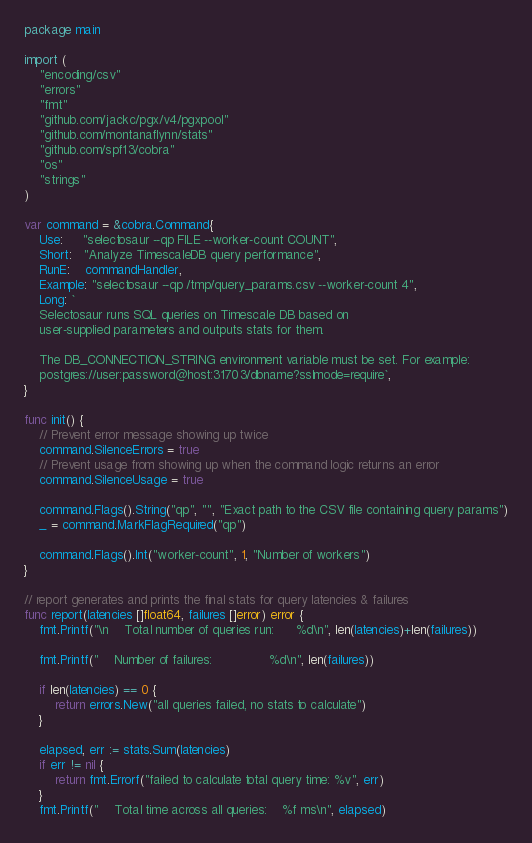<code> <loc_0><loc_0><loc_500><loc_500><_Go_>package main

import (
	"encoding/csv"
	"errors"
	"fmt"
	"github.com/jackc/pgx/v4/pgxpool"
	"github.com/montanaflynn/stats"
	"github.com/spf13/cobra"
	"os"
	"strings"
)

var command = &cobra.Command{
	Use:     "selectosaur --qp FILE --worker-count COUNT",
	Short:   "Analyze TimescaleDB query performance",
	RunE:    commandHandler,
	Example: "selectosaur --qp /tmp/query_params.csv --worker-count 4",
	Long: `
    Selectosaur runs SQL queries on Timescale DB based on
    user-supplied parameters and outputs stats for them.

    The DB_CONNECTION_STRING environment variable must be set. For example:
    postgres://user:password@host:31703/dbname?sslmode=require`,
}

func init() {
	// Prevent error message showing up twice
	command.SilenceErrors = true
	// Prevent usage from showing up when the command logic returns an error
	command.SilenceUsage = true

	command.Flags().String("qp", "", "Exact path to the CSV file containing query params")
	_ = command.MarkFlagRequired("qp")

	command.Flags().Int("worker-count", 1, "Number of workers")
}

// report generates and prints the final stats for query latencies & failures
func report(latencies []float64, failures []error) error {
	fmt.Printf("\n    Total number of queries run:      %d\n", len(latencies)+len(failures))

	fmt.Printf("    Number of failures:               %d\n", len(failures))

	if len(latencies) == 0 {
		return errors.New("all queries failed, no stats to calculate")
	}

	elapsed, err := stats.Sum(latencies)
	if err != nil {
		return fmt.Errorf("failed to calculate total query time: %v", err)
	}
	fmt.Printf("    Total time across all queries:    %f ms\n", elapsed)
</code> 